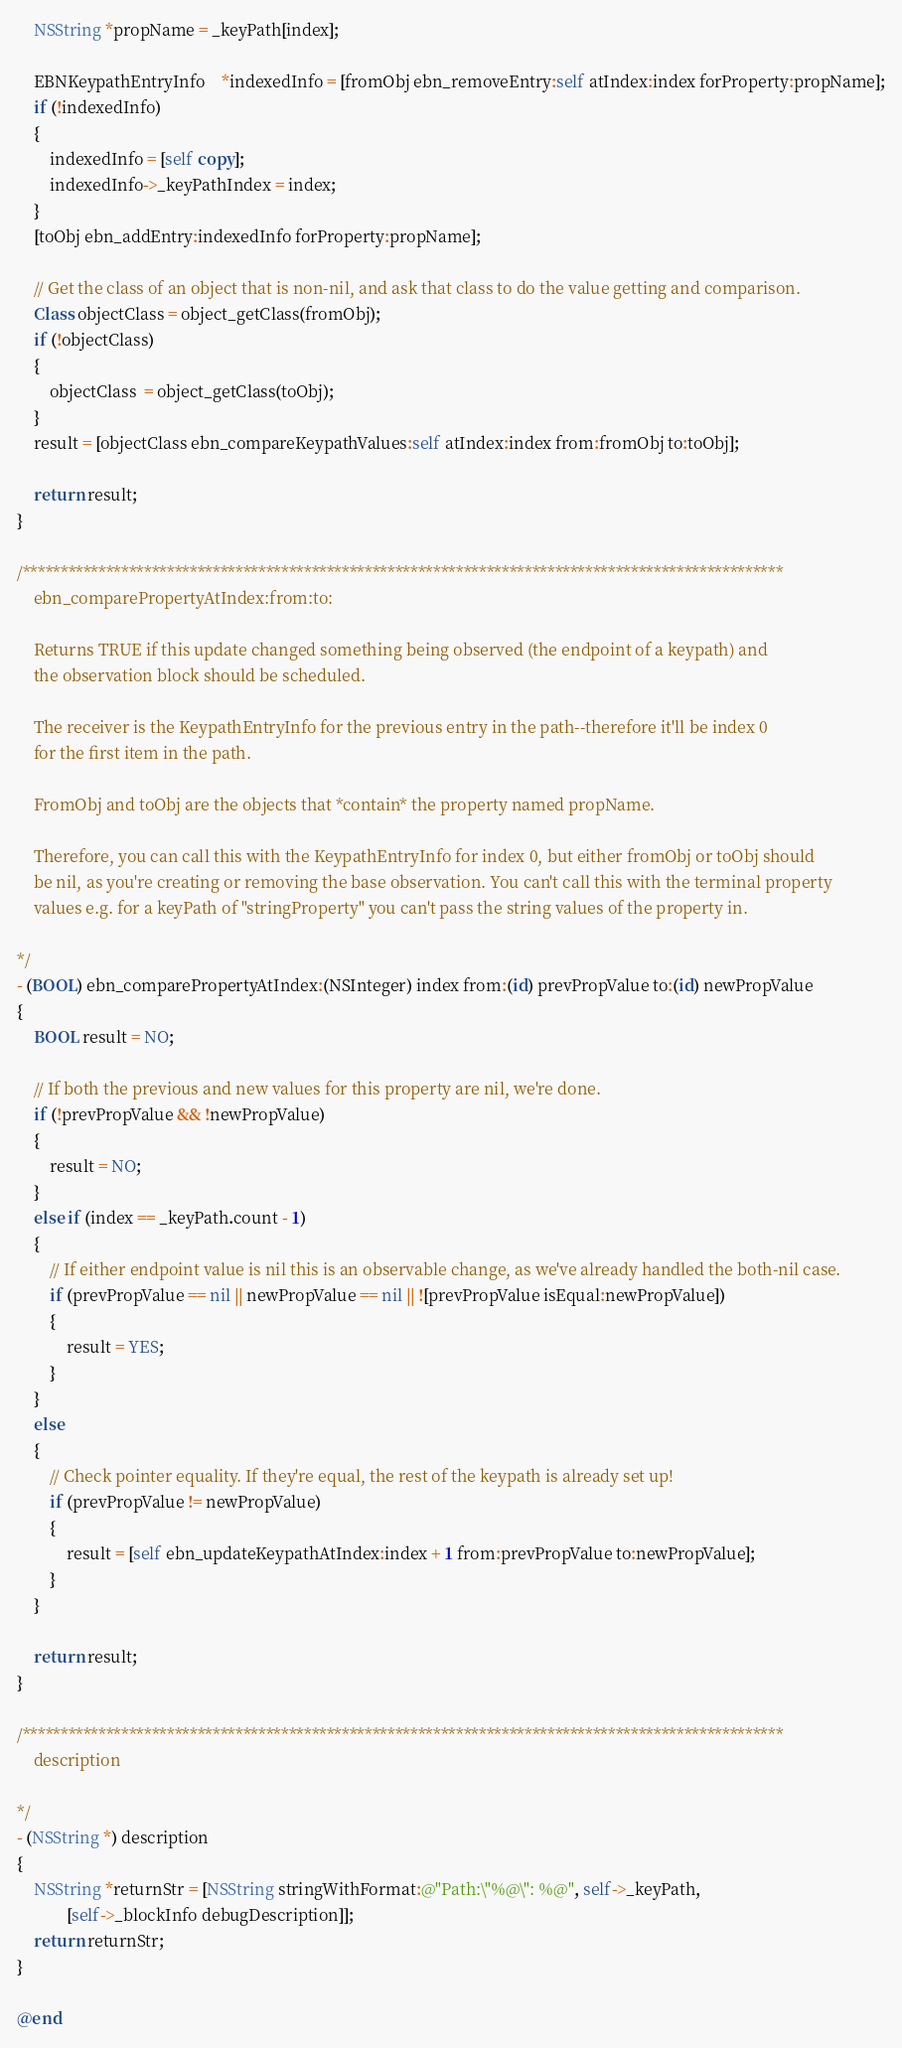<code> <loc_0><loc_0><loc_500><loc_500><_ObjectiveC_>	NSString *propName = _keyPath[index];
		
	EBNKeypathEntryInfo	*indexedInfo = [fromObj ebn_removeEntry:self atIndex:index forProperty:propName];
	if (!indexedInfo)
	{
		indexedInfo = [self copy];
		indexedInfo->_keyPathIndex = index;
	}
	[toObj ebn_addEntry:indexedInfo forProperty:propName];
	
	// Get the class of an object that is non-nil, and ask that class to do the value getting and comparison.
	Class objectClass = object_getClass(fromObj);
	if (!objectClass)
	{
		objectClass  = object_getClass(toObj);
	}
	result = [objectClass ebn_compareKeypathValues:self atIndex:index from:fromObj to:toObj];
	
	return result;
}

/****************************************************************************************************
	ebn_comparePropertyAtIndex:from:to:
    
 	Returns TRUE if this update changed something being observed (the endpoint of a keypath) and 
	the observation block should be scheduled.
	
	The receiver is the KeypathEntryInfo for the previous entry in the path--therefore it'll be index 0
	for the first item in the path.
	
	FromObj and toObj are the objects that *contain* the property named propName.
	
	Therefore, you can call this with the KeypathEntryInfo for index 0, but either fromObj or toObj should
	be nil, as you're creating or removing the base observation. You can't call this with the terminal property
	values e.g. for a keyPath of "stringProperty" you can't pass the string values of the property in.
   
*/
- (BOOL) ebn_comparePropertyAtIndex:(NSInteger) index from:(id) prevPropValue to:(id) newPropValue
{
	BOOL result = NO;
	
	// If both the previous and new values for this property are nil, we're done.
	if (!prevPropValue && !newPropValue)
	{
		result = NO;
	}
	else if (index == _keyPath.count - 1)
	{
		// If either endpoint value is nil this is an observable change, as we've already handled the both-nil case.
		if (prevPropValue == nil || newPropValue == nil || ![prevPropValue isEqual:newPropValue])
		{
			result = YES;
		}
	}
	else
	{
		// Check pointer equality. If they're equal, the rest of the keypath is already set up!
		if (prevPropValue != newPropValue)
		{
			result = [self ebn_updateKeypathAtIndex:index + 1 from:prevPropValue to:newPropValue];
		}
	}
	
	return result;
}

/****************************************************************************************************
	description
	
*/
- (NSString *) description
{
	NSString *returnStr = [NSString stringWithFormat:@"Path:\"%@\": %@", self->_keyPath,
			[self->_blockInfo debugDescription]];
	return returnStr;
}

@end

</code> 